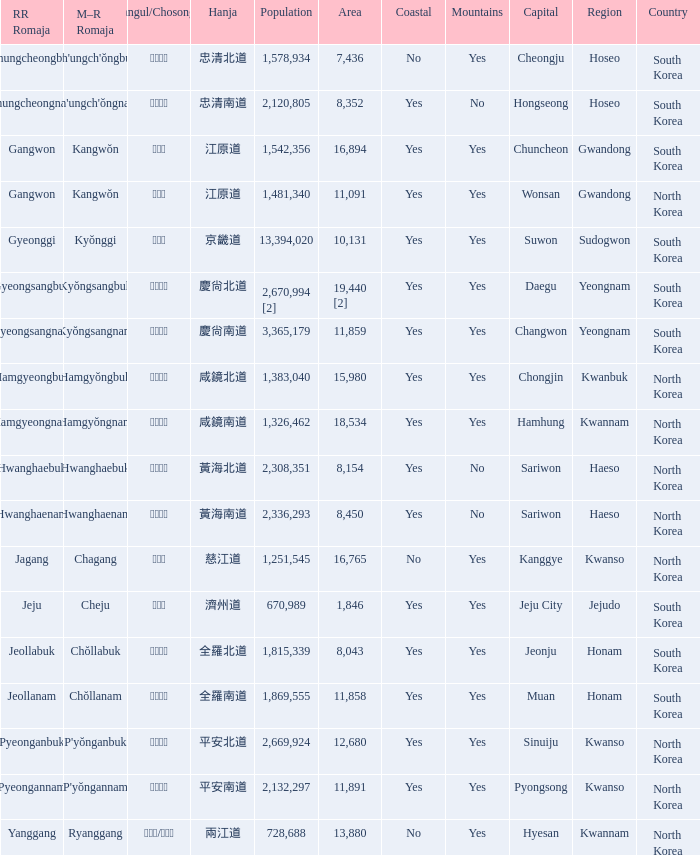What is the area for the province having Hangul of 경기도? 10131.0. 